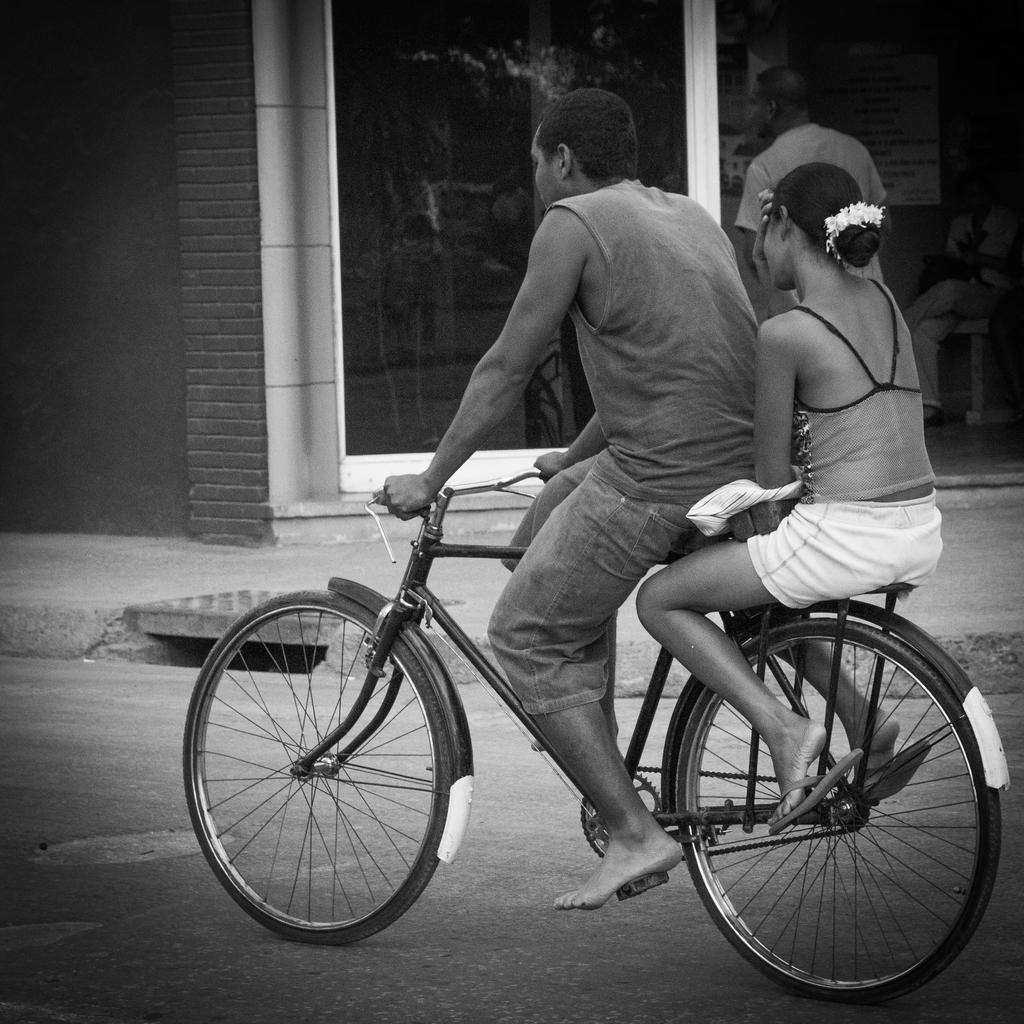How would you summarize this image in a sentence or two? In this image there are two persons, one woman and one man. Man is riding a bicycle and woman is sitting behind him. In the background there is a store and another person is moving. 